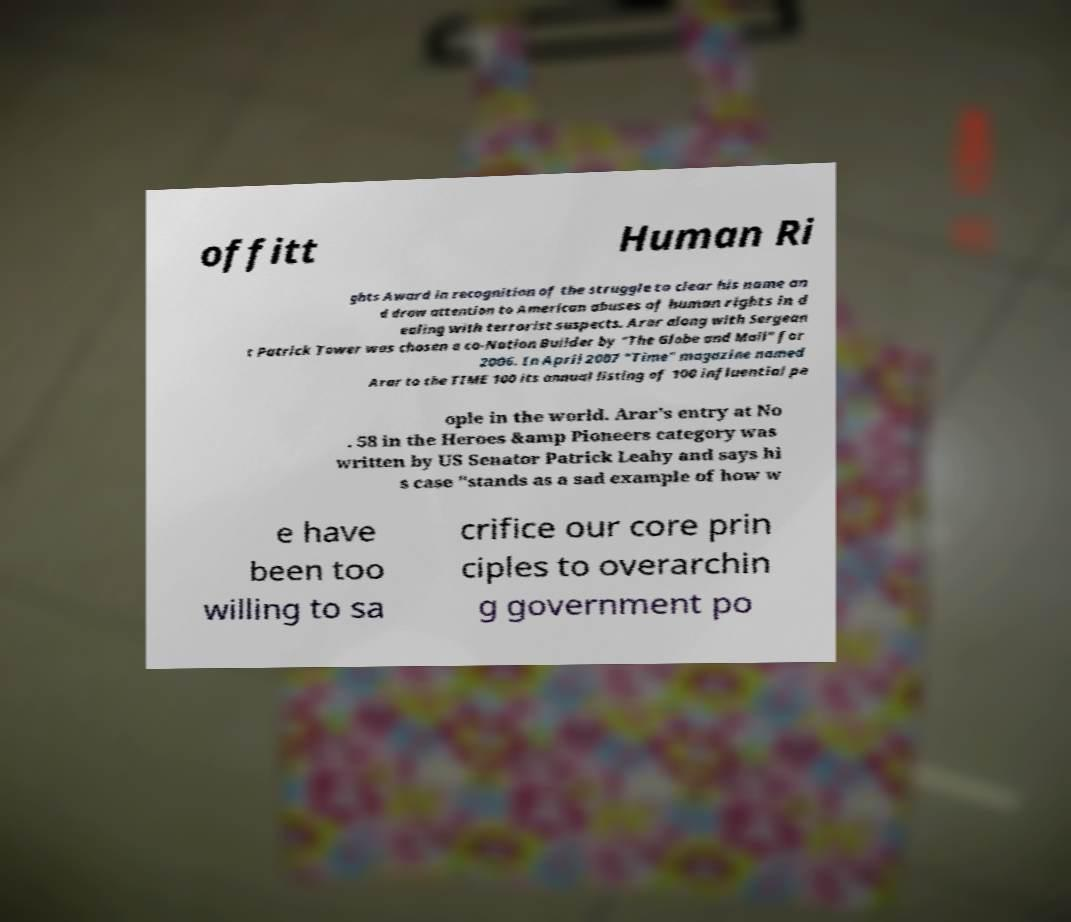I need the written content from this picture converted into text. Can you do that? offitt Human Ri ghts Award in recognition of the struggle to clear his name an d draw attention to American abuses of human rights in d ealing with terrorist suspects. Arar along with Sergean t Patrick Tower was chosen a co-Nation Builder by "The Globe and Mail" for 2006. In April 2007 "Time" magazine named Arar to the TIME 100 its annual listing of 100 influential pe ople in the world. Arar's entry at No . 58 in the Heroes &amp Pioneers category was written by US Senator Patrick Leahy and says hi s case "stands as a sad example of how w e have been too willing to sa crifice our core prin ciples to overarchin g government po 